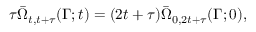Convert formula to latex. <formula><loc_0><loc_0><loc_500><loc_500>\tau \bar { \Omega } _ { t , t + \tau } ( \Gamma ; t ) = ( 2 t + \tau ) \bar { \Omega } _ { 0 , 2 t + \tau } ( \Gamma ; 0 ) ,</formula> 